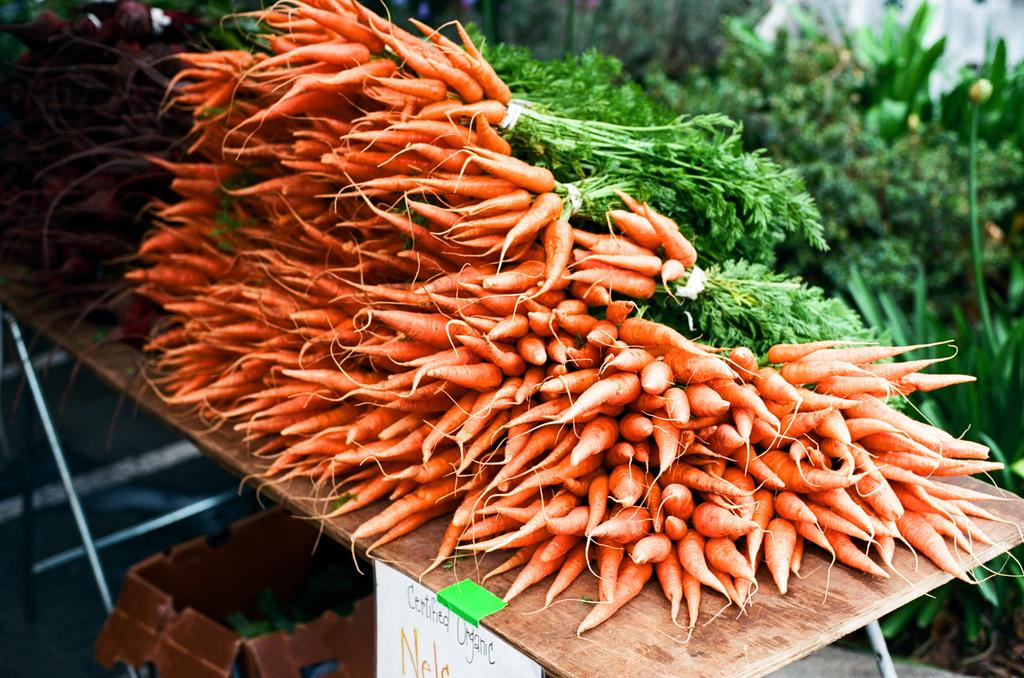What is the main subject in the center of the image? There are carrots in the center of the image. Where are the carrots located? The carrots are placed on a table. What can be seen in the background of the image? There are plants in the background of the image. How many chickens are standing on the cloud in the image? There are no chickens or clouds present in the image; it features carrots on a table with plants in the background. 